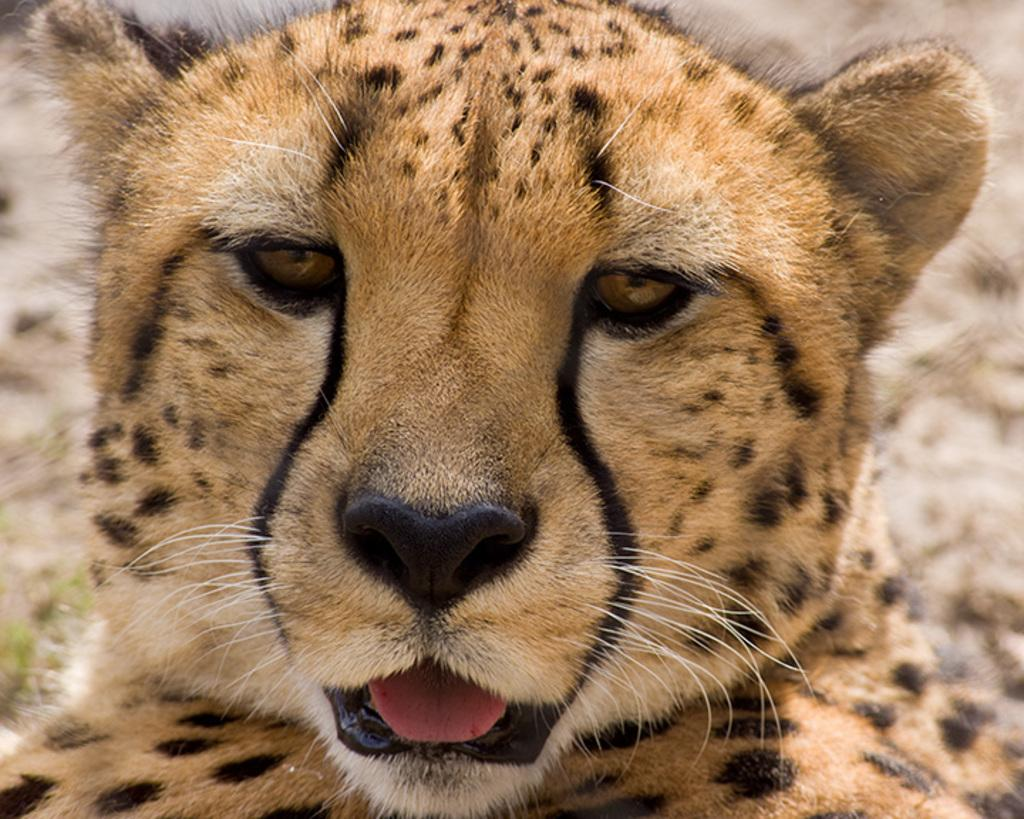What type of animal is in the image? There is a cheetah in the image. What type of authority does the cheetah have in the image? The image does not depict any authority or hierarchy; it simply shows a cheetah. Can you see a net in the image? There is no net present in the image. 